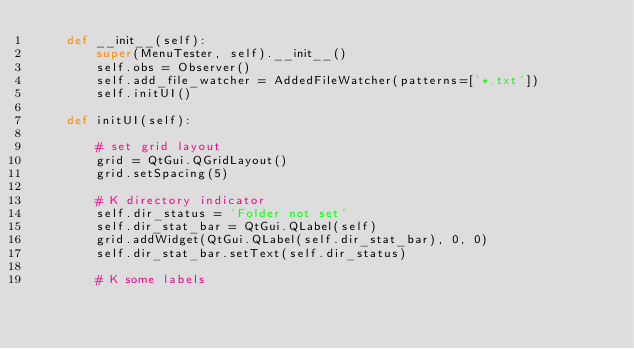<code> <loc_0><loc_0><loc_500><loc_500><_Python_>    def __init__(self):
        super(MenuTester, self).__init__()
        self.obs = Observer()
        self.add_file_watcher = AddedFileWatcher(patterns=['*.txt'])
        self.initUI()

    def initUI(self):

        # set grid layout
        grid = QtGui.QGridLayout()
        grid.setSpacing(5)

        # K directory indicator
        self.dir_status = 'Folder not set'
        self.dir_stat_bar = QtGui.QLabel(self)
        grid.addWidget(QtGui.QLabel(self.dir_stat_bar), 0, 0)
        self.dir_stat_bar.setText(self.dir_status)

        # K some labels</code> 